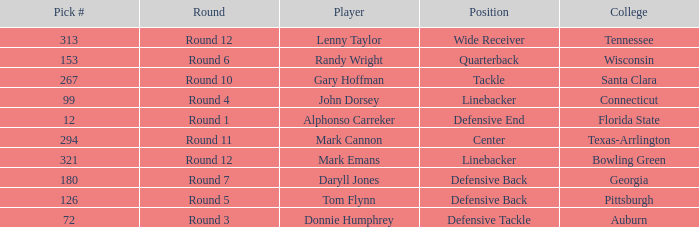What is Mark Cannon's College? Texas-Arrlington. 